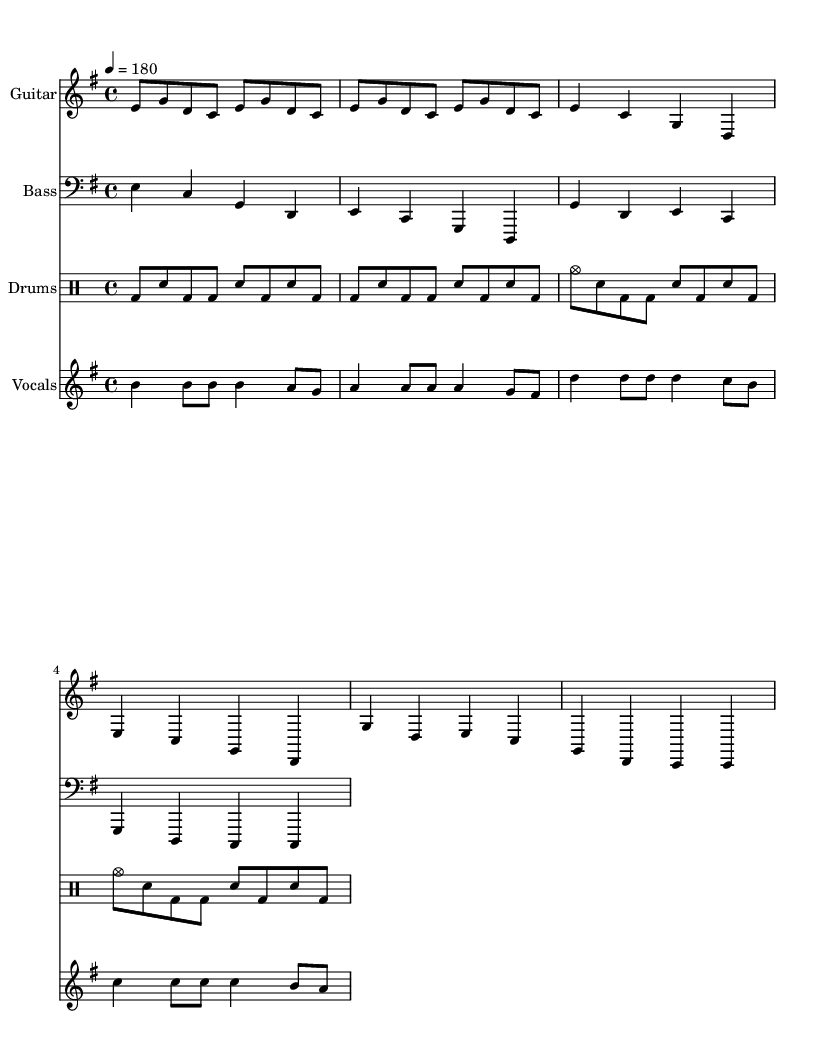What is the key signature of this music? The key signature is E minor, which has one sharp (F#). This can be identified from the key signature indication at the beginning of the sheet music.
Answer: E minor What is the time signature of the piece? The time signature is 4/4, as denoted at the beginning of the score. This means there are four beats per measure, with each beat being a quarter note.
Answer: 4/4 What is the tempo marking for this piece? The tempo marking indicates a speed of quarter note equals 180 beats per minute. This is stated in the tempo annotation at the beginning of the score.
Answer: 180 How many measures are in the guitar verse section? The guitar verse section consists of 4 measures, which can be counted by identifying the end of each measure marked by vertical lines in the guitar staff.
Answer: 4 What are the main vocal notes in the chorus? The main vocal notes in the chorus are D, C, and B. By examining the vocal staff during the chorus, identifying the notes played in sequence gives this answer.
Answer: D, C, B What type of drum pattern is used in the verse? The drum pattern in the verse is a basic rock pattern, featuring a combination of bass drum and snare placements that create a driving rhythm typical for punk music.
Answer: Rock pattern What is the distinguishing characteristic of the guitar riff? The guitar riff is characterized by repeating eighth notes, which creates a fast-paced, driving sound, common in punk music to evoke energy and adrenaline akin to racing.
Answer: Repeating eighth notes 